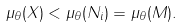Convert formula to latex. <formula><loc_0><loc_0><loc_500><loc_500>\mu _ { \theta } ( X ) < \mu _ { \theta } ( N _ { i } ) = \mu _ { \theta } ( M ) .</formula> 